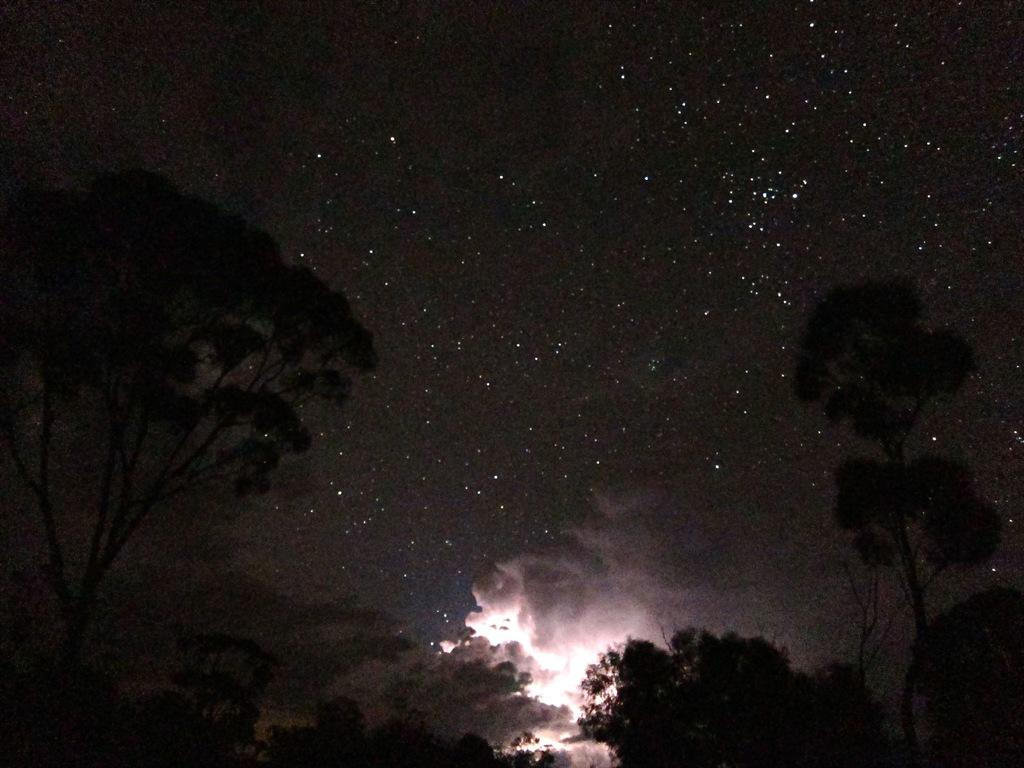What type of vegetation is in the front of the image? There are trees in the front of the image. What celestial objects can be seen in the image? Stars are visible in the image. What is present at the top of the image? The sky is present at the top of the image. What substance appears to be rising from the bottom of the image? There appears to be smoke at the bottom of the image. How does the image compare to a picture of a cat? The image does not compare to a picture of a cat, as there are no cats present in the image. What is the profit generated by the stars in the image? There is no mention of profit in the image, as it is a natural scene featuring stars and other elements. 